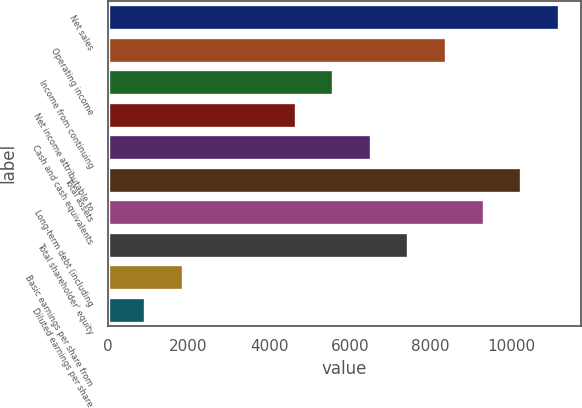Convert chart. <chart><loc_0><loc_0><loc_500><loc_500><bar_chart><fcel>Net sales<fcel>Operating income<fcel>Income from continuing<fcel>Net income attributable to<fcel>Cash and cash equivalents<fcel>Total assets<fcel>Long-term debt (including<fcel>Total shareholder' equity<fcel>Basic earnings per share from<fcel>Diluted earnings per share<nl><fcel>11182.8<fcel>8387.25<fcel>5591.64<fcel>4659.77<fcel>6523.51<fcel>10251<fcel>9319.11<fcel>7455.38<fcel>1864.18<fcel>932.32<nl></chart> 